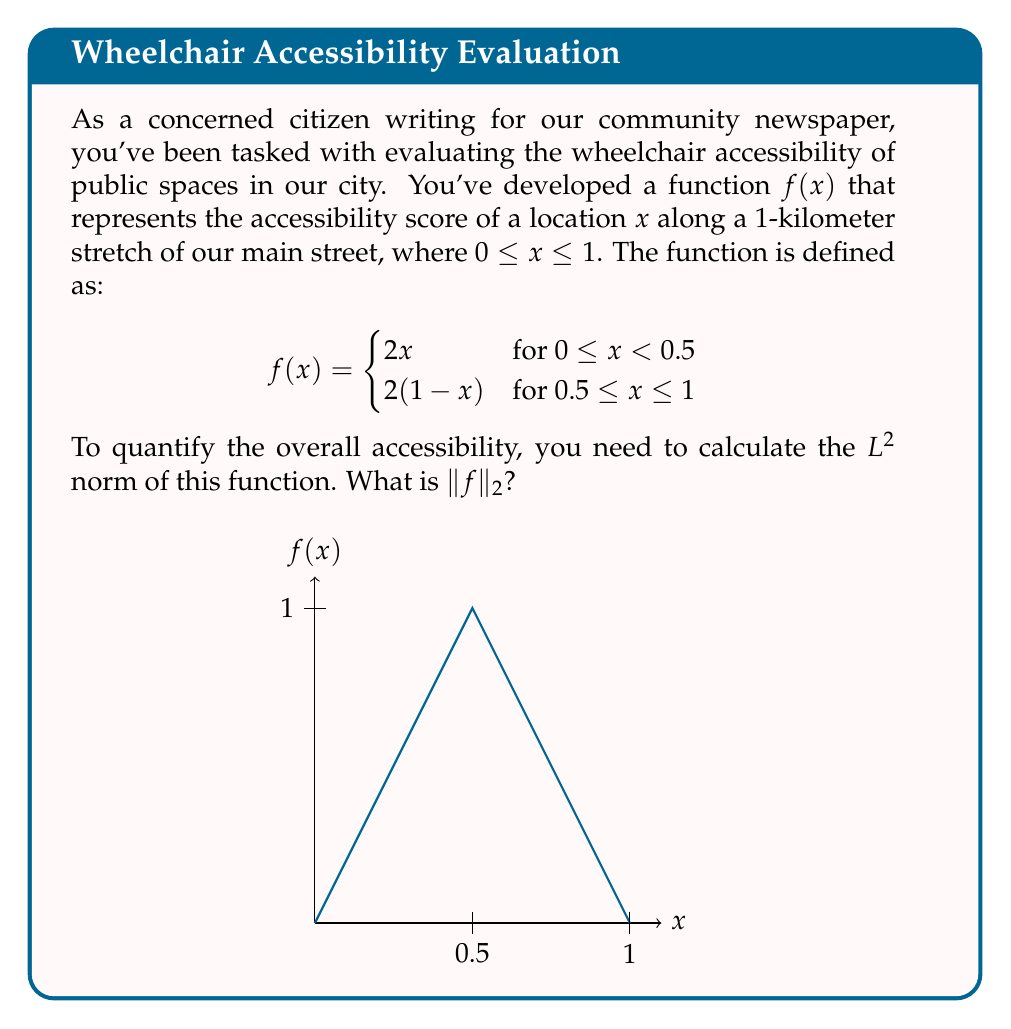Could you help me with this problem? Let's approach this step-by-step:

1) The $L^2$ norm of a function $f$ on an interval $[a,b]$ is defined as:

   $$\|f\|_2 = \left(\int_a^b |f(x)|^2 dx\right)^{1/2}$$

2) In our case, we need to split the integral into two parts due to the piecewise definition:

   $$\|f\|_2 = \left(\int_0^{0.5} (2x)^2 dx + \int_{0.5}^1 (2(1-x))^2 dx\right)^{1/2}$$

3) Let's evaluate the first integral:

   $$\int_0^{0.5} (2x)^2 dx = 4\int_0^{0.5} x^2 dx = 4 \cdot \frac{x^3}{3}\bigg|_0^{0.5} = 4 \cdot \frac{(0.5)^3}{3} = \frac{1}{6}$$

4) Now the second integral:

   $$\int_{0.5}^1 (2(1-x))^2 dx = 4\int_{0.5}^1 (1-x)^2 dx = 4 \cdot \left(-\frac{(1-x)^3}{3}\right)\bigg|_{0.5}^1 = 4 \cdot \frac{(0.5)^3}{3} = \frac{1}{6}$$

5) Adding these together:

   $$\|f\|_2 = \left(\frac{1}{6} + \frac{1}{6}\right)^{1/2} = \left(\frac{1}{3}\right)^{1/2} = \frac{1}{\sqrt{3}}$$

This result quantifies the overall accessibility of the street, taking into account variations along its length.
Answer: $\frac{1}{\sqrt{3}}$ 